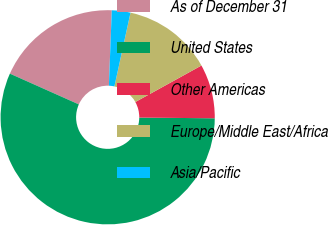<chart> <loc_0><loc_0><loc_500><loc_500><pie_chart><fcel>As of December 31<fcel>United States<fcel>Other Americas<fcel>Europe/Middle East/Africa<fcel>Asia/Pacific<nl><fcel>18.93%<fcel>56.53%<fcel>8.18%<fcel>13.55%<fcel>2.81%<nl></chart> 